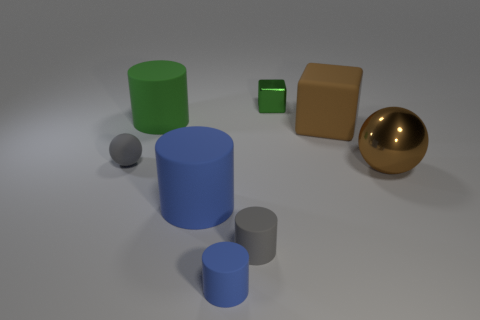What shape is the metallic object in front of the tiny thing behind the green matte thing?
Your answer should be very brief. Sphere. What number of blue things are to the right of the tiny blue cylinder?
Your answer should be very brief. 0. Are there any tiny purple cubes made of the same material as the green cylinder?
Your response must be concise. No. There is a blue cylinder that is the same size as the brown block; what material is it?
Your response must be concise. Rubber. How big is the thing that is both right of the tiny gray cylinder and behind the big brown rubber thing?
Provide a short and direct response. Small. The rubber thing that is to the right of the green rubber cylinder and behind the gray ball is what color?
Your answer should be very brief. Brown. Is the number of rubber objects right of the big matte cube less than the number of brown matte things that are to the right of the green cylinder?
Offer a terse response. Yes. How many large brown rubber objects are the same shape as the large brown metal object?
Your answer should be very brief. 0. There is a green cube that is made of the same material as the large sphere; what is its size?
Give a very brief answer. Small. What color is the cylinder that is behind the sphere that is right of the small blue matte cylinder?
Your answer should be compact. Green. 